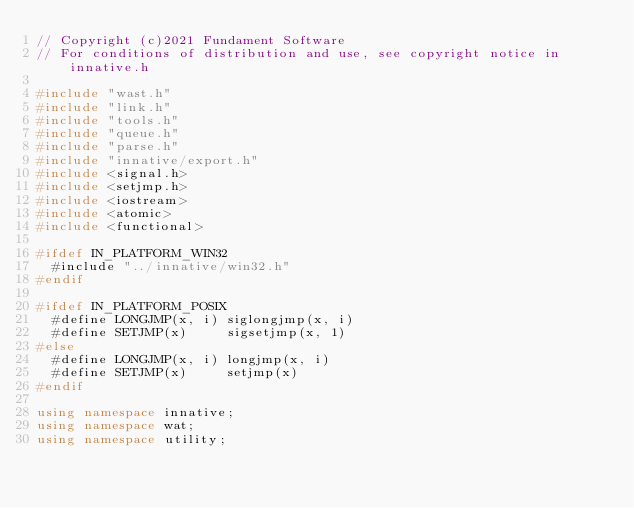Convert code to text. <code><loc_0><loc_0><loc_500><loc_500><_C++_>// Copyright (c)2021 Fundament Software
// For conditions of distribution and use, see copyright notice in innative.h

#include "wast.h"
#include "link.h"
#include "tools.h"
#include "queue.h"
#include "parse.h"
#include "innative/export.h"
#include <signal.h>
#include <setjmp.h>
#include <iostream>
#include <atomic>
#include <functional>

#ifdef IN_PLATFORM_WIN32
  #include "../innative/win32.h"
#endif

#ifdef IN_PLATFORM_POSIX
  #define LONGJMP(x, i) siglongjmp(x, i)
  #define SETJMP(x)     sigsetjmp(x, 1)
#else
  #define LONGJMP(x, i) longjmp(x, i)
  #define SETJMP(x)     setjmp(x)
#endif

using namespace innative;
using namespace wat;
using namespace utility;</code> 